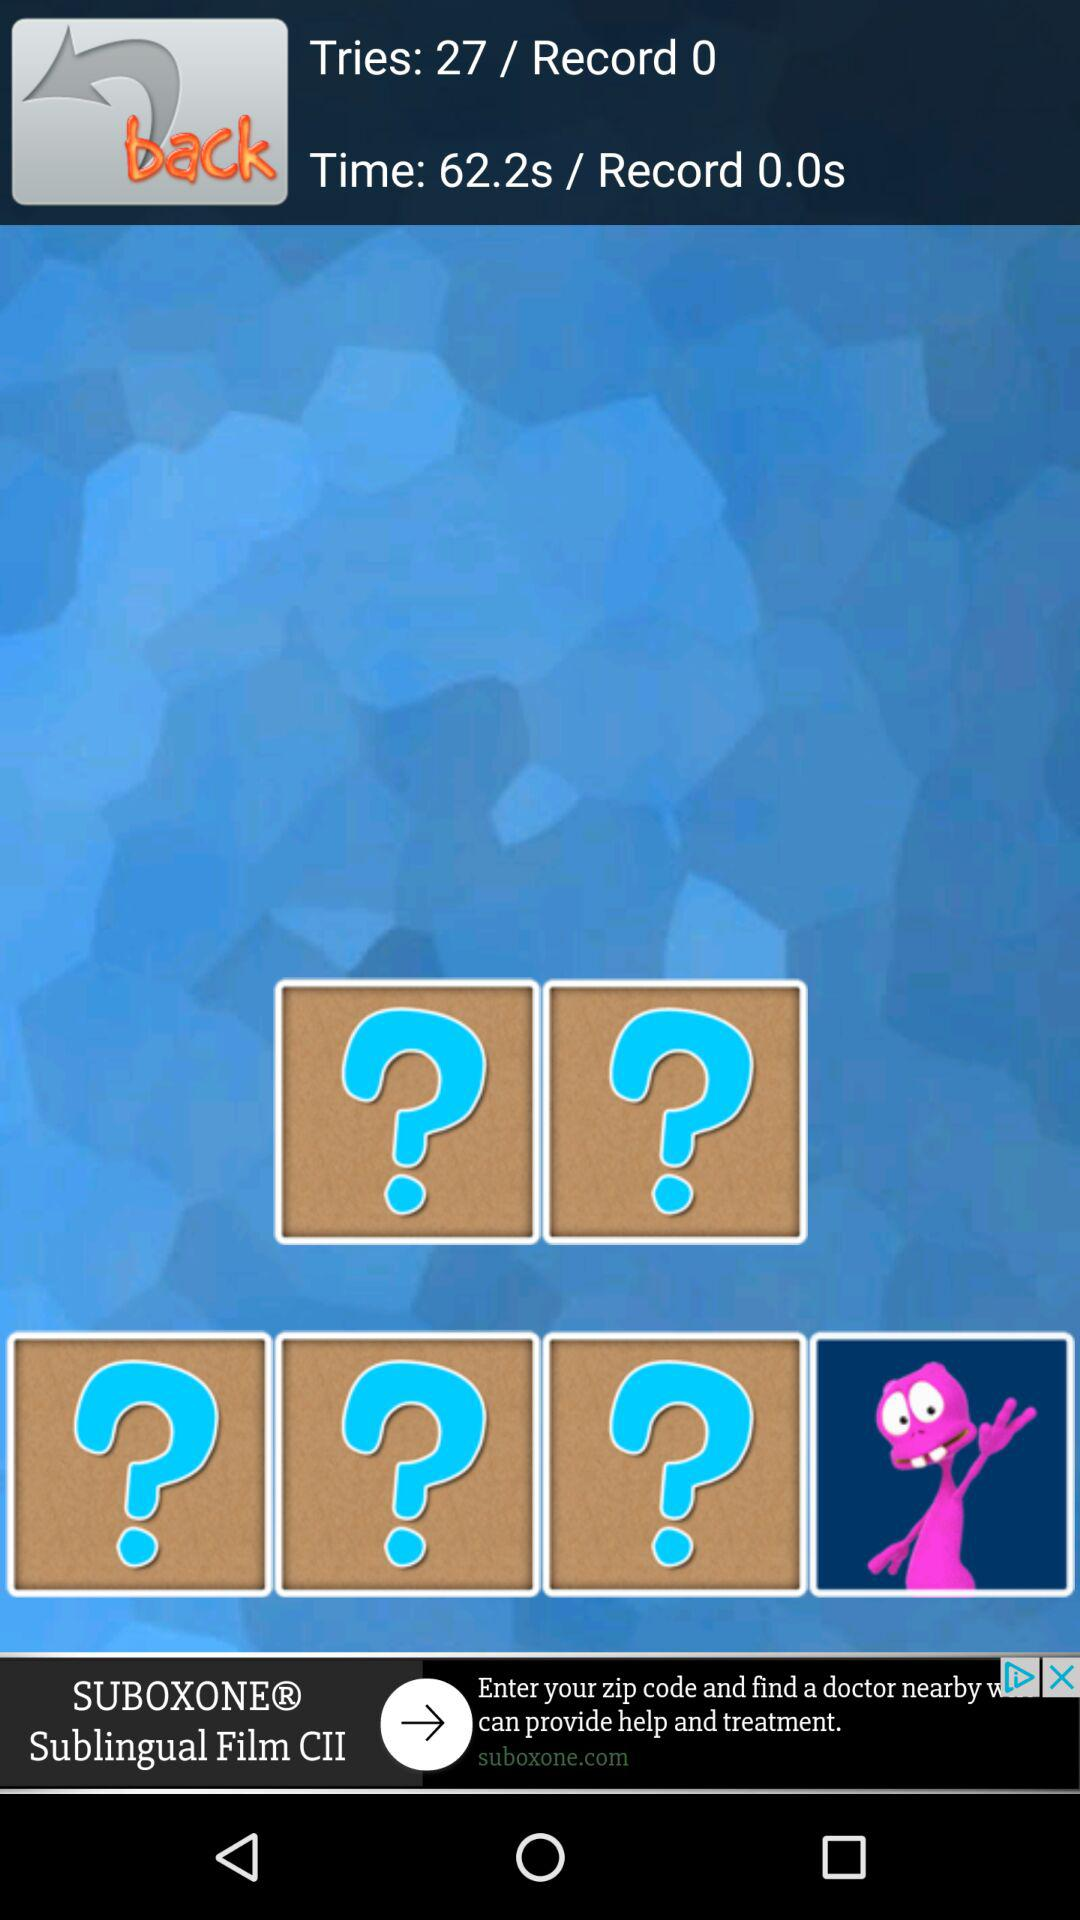What is the time duration? The time duration is 62.2 seconds. 